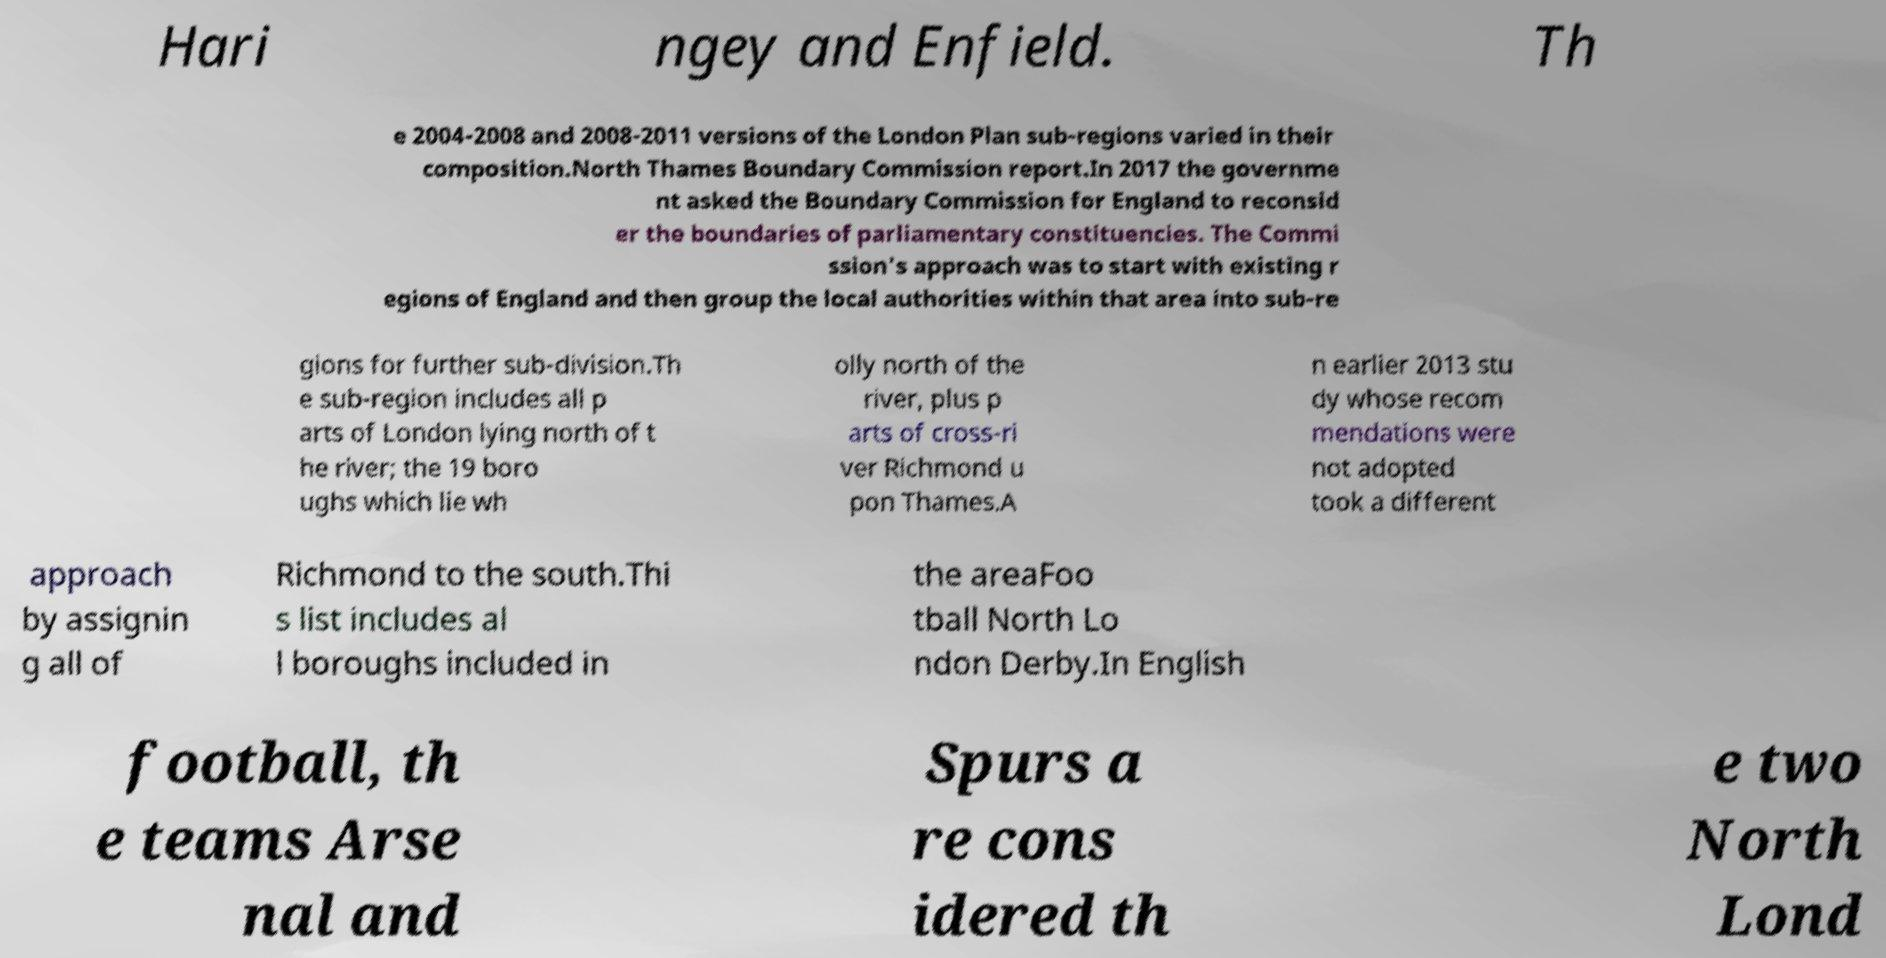Could you assist in decoding the text presented in this image and type it out clearly? Hari ngey and Enfield. Th e 2004-2008 and 2008-2011 versions of the London Plan sub-regions varied in their composition.North Thames Boundary Commission report.In 2017 the governme nt asked the Boundary Commission for England to reconsid er the boundaries of parliamentary constituencies. The Commi ssion's approach was to start with existing r egions of England and then group the local authorities within that area into sub-re gions for further sub-division.Th e sub-region includes all p arts of London lying north of t he river; the 19 boro ughs which lie wh olly north of the river, plus p arts of cross-ri ver Richmond u pon Thames.A n earlier 2013 stu dy whose recom mendations were not adopted took a different approach by assignin g all of Richmond to the south.Thi s list includes al l boroughs included in the areaFoo tball North Lo ndon Derby.In English football, th e teams Arse nal and Spurs a re cons idered th e two North Lond 